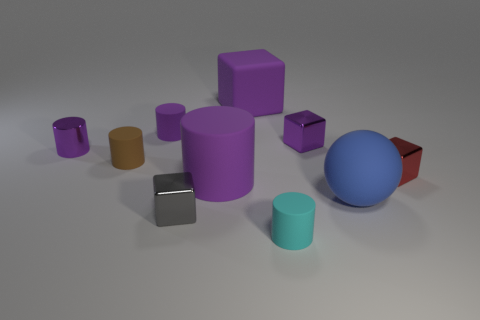Subtract all purple metallic cylinders. How many cylinders are left? 4 Subtract all gray blocks. How many blocks are left? 3 Subtract all blocks. How many objects are left? 6 Subtract 3 cylinders. How many cylinders are left? 2 Subtract all cyan cubes. Subtract all blue spheres. How many cubes are left? 4 Subtract all blue balls. How many brown blocks are left? 0 Subtract all large purple things. Subtract all red things. How many objects are left? 7 Add 1 metallic cylinders. How many metallic cylinders are left? 2 Add 8 small brown metallic blocks. How many small brown metallic blocks exist? 8 Subtract 1 purple blocks. How many objects are left? 9 